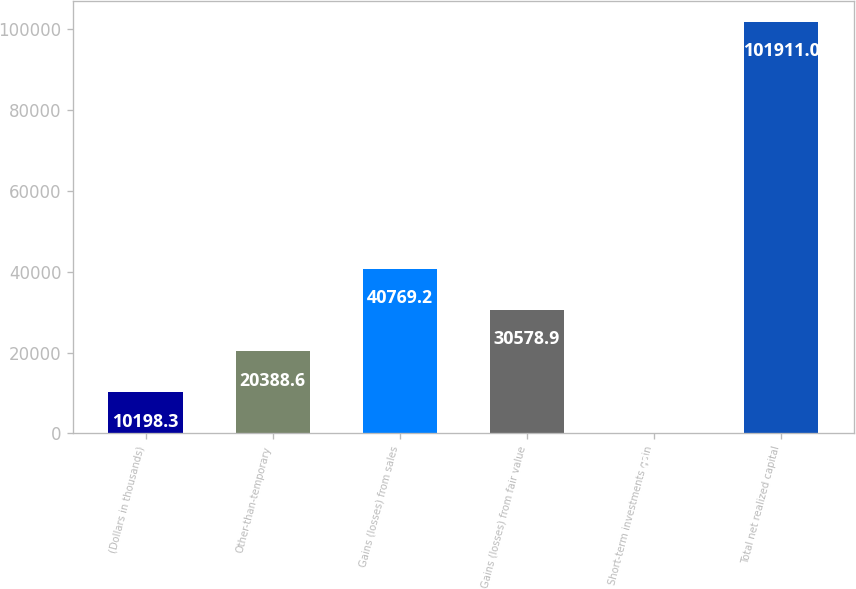Convert chart. <chart><loc_0><loc_0><loc_500><loc_500><bar_chart><fcel>(Dollars in thousands)<fcel>Other-than-temporary<fcel>Gains (losses) from sales<fcel>Gains (losses) from fair value<fcel>Short-term investments gain<fcel>Total net realized capital<nl><fcel>10198.3<fcel>20388.6<fcel>40769.2<fcel>30578.9<fcel>8<fcel>101911<nl></chart> 